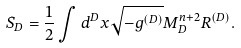<formula> <loc_0><loc_0><loc_500><loc_500>S _ { D } = \frac { 1 } { 2 } \int d ^ { D } x \sqrt { - g ^ { ( D ) } } M _ { D } ^ { n + 2 } R ^ { ( D ) } .</formula> 